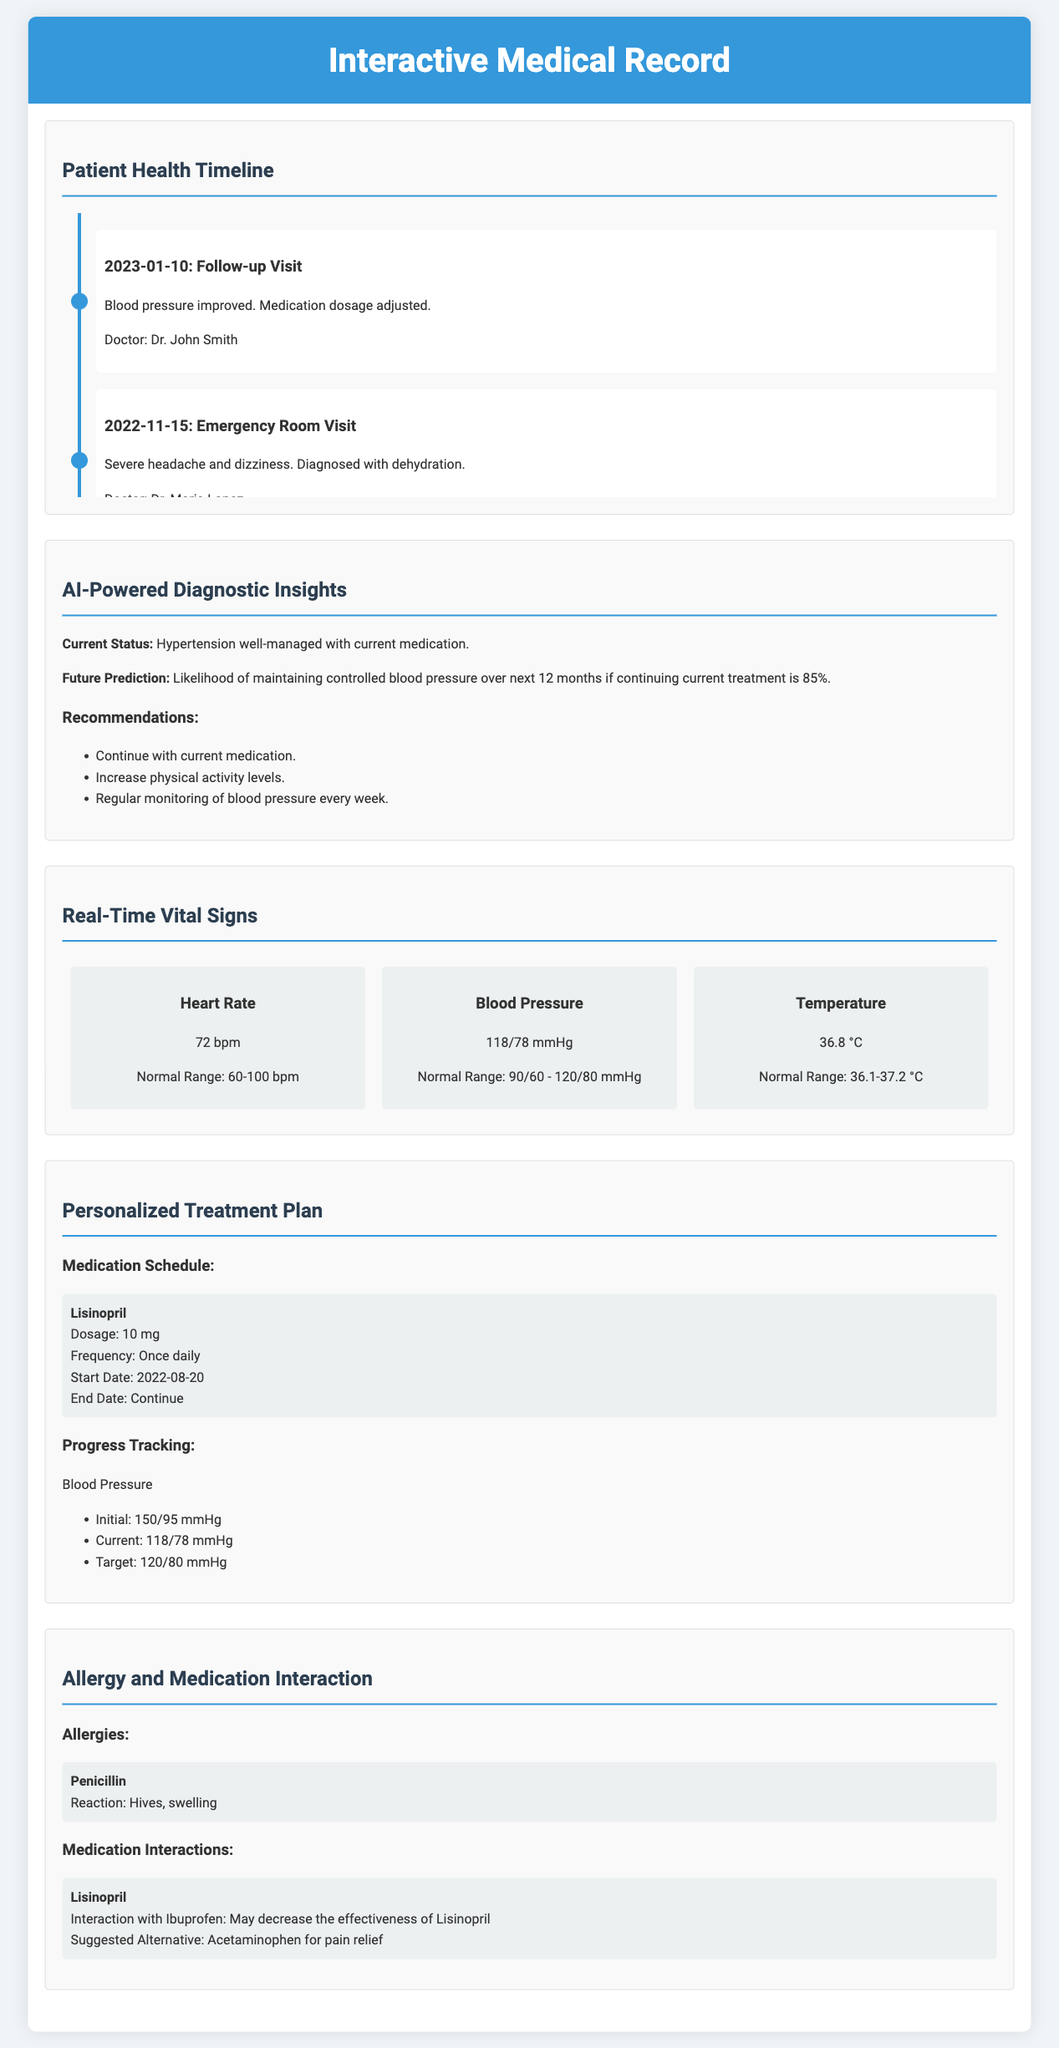What date was the follow-up visit? The follow-up visit date is listed in the patient timeline section under the corresponding event.
Answer: 2023-01-10 Who was the doctor during the emergency room visit? The doctor for the emergency room visit is specified in the timeline details.
Answer: Dr. Maria Lopez What is the patient's current blood pressure reading? The current blood pressure is found in the real-time vital signs section.
Answer: 118/78 mmHg What is the recommendation for monitoring blood pressure? This recommendation can be found in the AI-Powered Diagnostic Insights section related to patient management.
Answer: Regular monitoring of blood pressure every week What was the initial blood pressure recorded? The initial blood pressure can be found under progress tracking in the personalized treatment plan.
Answer: 150/95 mmHg What type of reaction does the patient have to penicillin? The document specifies the type of reaction under the allergies section.
Answer: Hives, swelling What alternative medication is suggested for pain relief? This alternative medication is specified in the medication interactions section.
Answer: Acetaminophen What dosage of Lisinopril is prescribed? The prescribed dosage for Lisinopril is mentioned in the medication schedule of the treatment plan.
Answer: 10 mg 